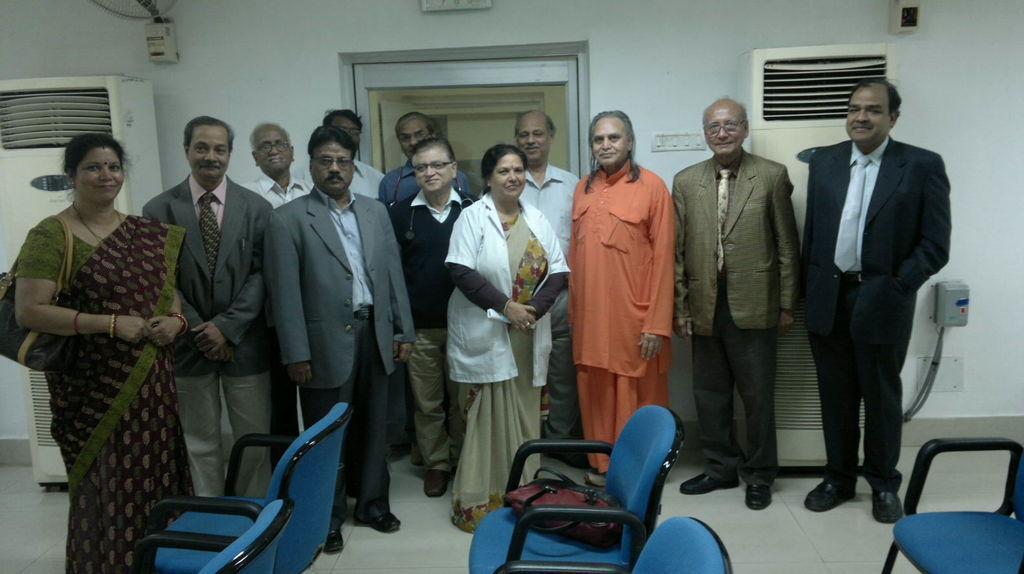Describe this image in one or two sentences. In this image we can see a few people, there are chairs, there is a bag on a chair, there are two air conditioners, there is a switchboard, also we can see the wall, and a door.  